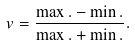Convert formula to latex. <formula><loc_0><loc_0><loc_500><loc_500>v = \frac { { \max . } - { \min . } } { { \max . } + { \min . } } .</formula> 